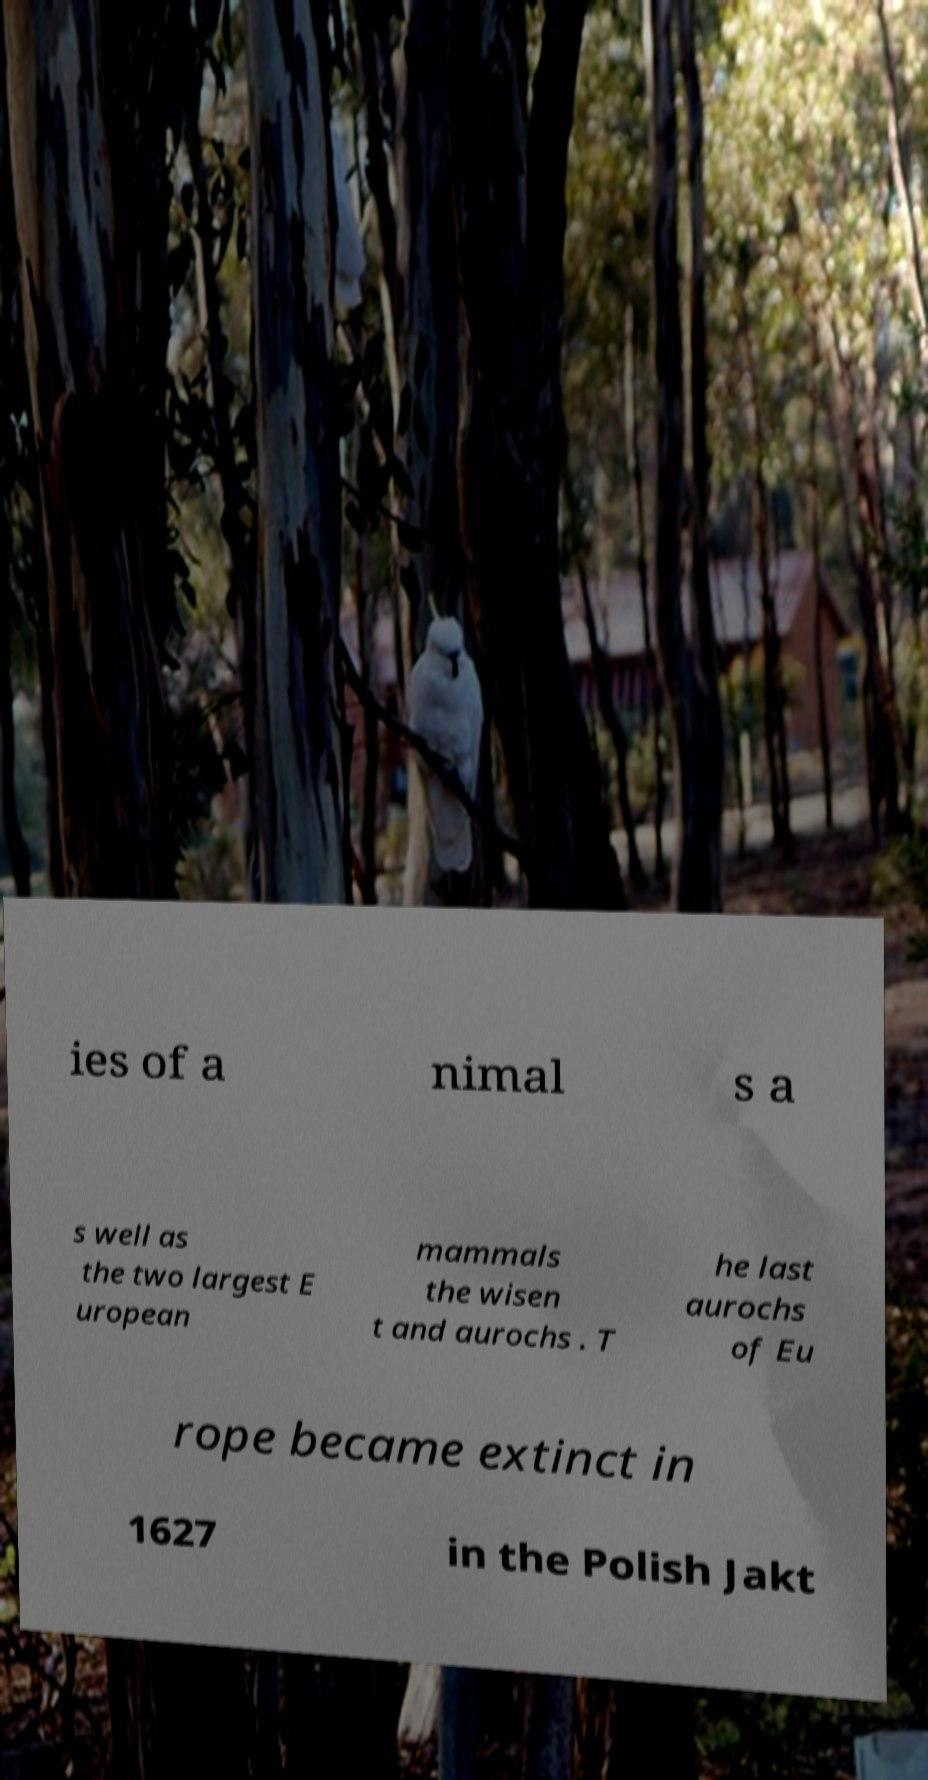Please identify and transcribe the text found in this image. ies of a nimal s a s well as the two largest E uropean mammals the wisen t and aurochs . T he last aurochs of Eu rope became extinct in 1627 in the Polish Jakt 